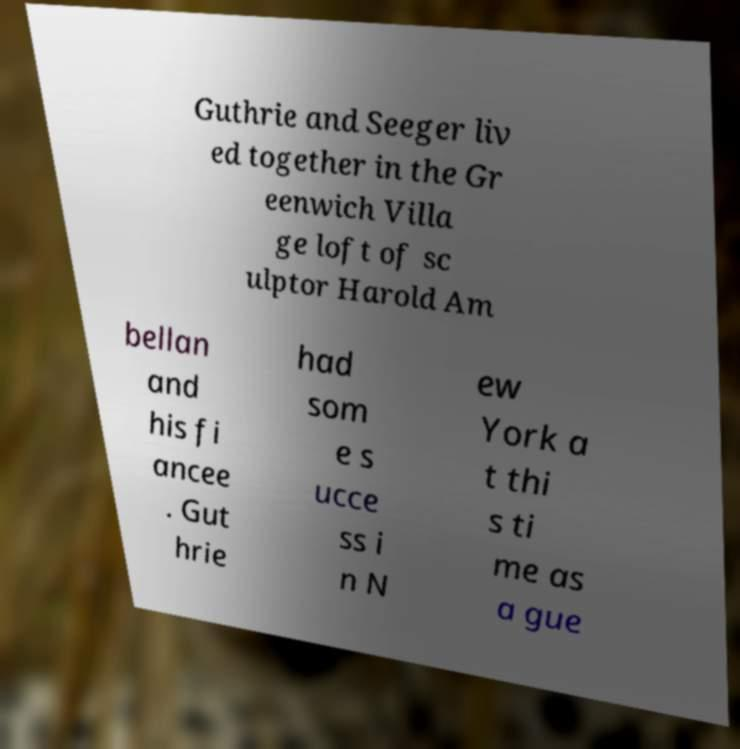Please read and relay the text visible in this image. What does it say? Guthrie and Seeger liv ed together in the Gr eenwich Villa ge loft of sc ulptor Harold Am bellan and his fi ancee . Gut hrie had som e s ucce ss i n N ew York a t thi s ti me as a gue 